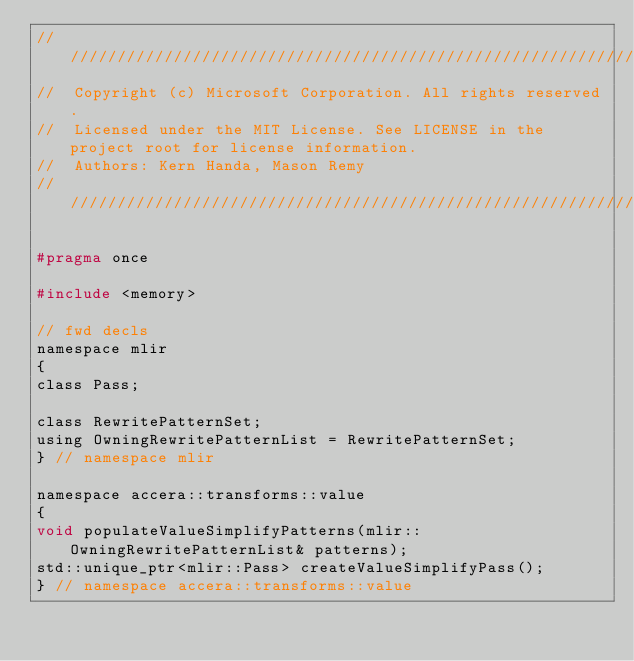Convert code to text. <code><loc_0><loc_0><loc_500><loc_500><_C_>////////////////////////////////////////////////////////////////////////////////////////////////////
//  Copyright (c) Microsoft Corporation. All rights reserved.
//  Licensed under the MIT License. See LICENSE in the project root for license information.
//  Authors: Kern Handa, Mason Remy
////////////////////////////////////////////////////////////////////////////////////////////////////

#pragma once

#include <memory>

// fwd decls
namespace mlir
{
class Pass;

class RewritePatternSet;
using OwningRewritePatternList = RewritePatternSet;
} // namespace mlir

namespace accera::transforms::value
{
void populateValueSimplifyPatterns(mlir::OwningRewritePatternList& patterns);
std::unique_ptr<mlir::Pass> createValueSimplifyPass();
} // namespace accera::transforms::value
</code> 